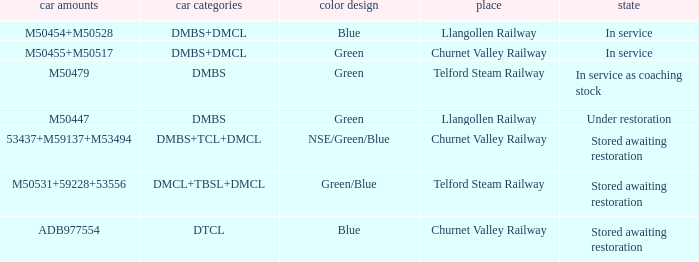What status is the vehicle types of dmbs+tcl+dmcl? Stored awaiting restoration. 